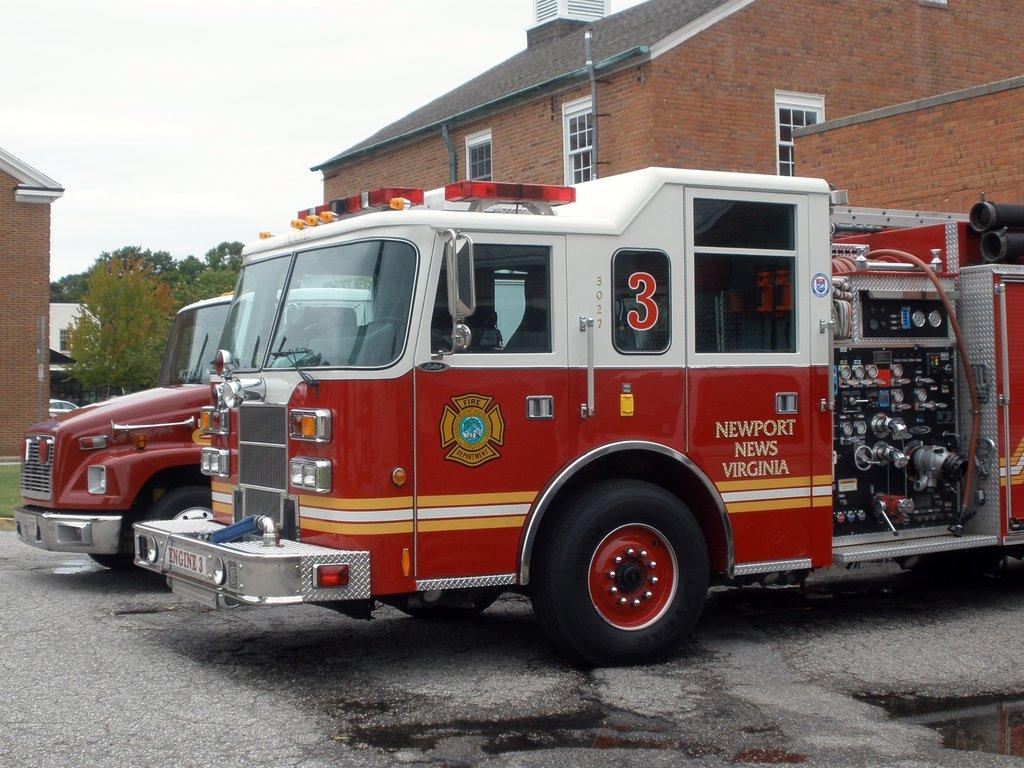What type of vehicles are present in the image? There are fire trucks in the image. What other type of vehicle can be seen in the image? There is a car in the image. What structures are visible in the image? There are buildings in the image. What type of natural elements are present in the image? There are trees in the image. What arithmetic problem is being solved by the trees in the image? There is no arithmetic problem being solved by the trees in the image, as trees are not capable of performing arithmetic. 